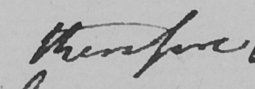Please transcribe the handwritten text in this image. therefore 